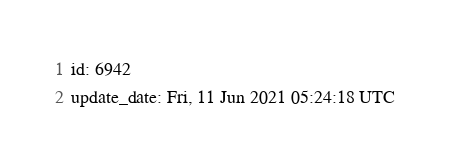Convert code to text. <code><loc_0><loc_0><loc_500><loc_500><_YAML_>id: 6942
update_date: Fri, 11 Jun 2021 05:24:18 UTC
</code> 